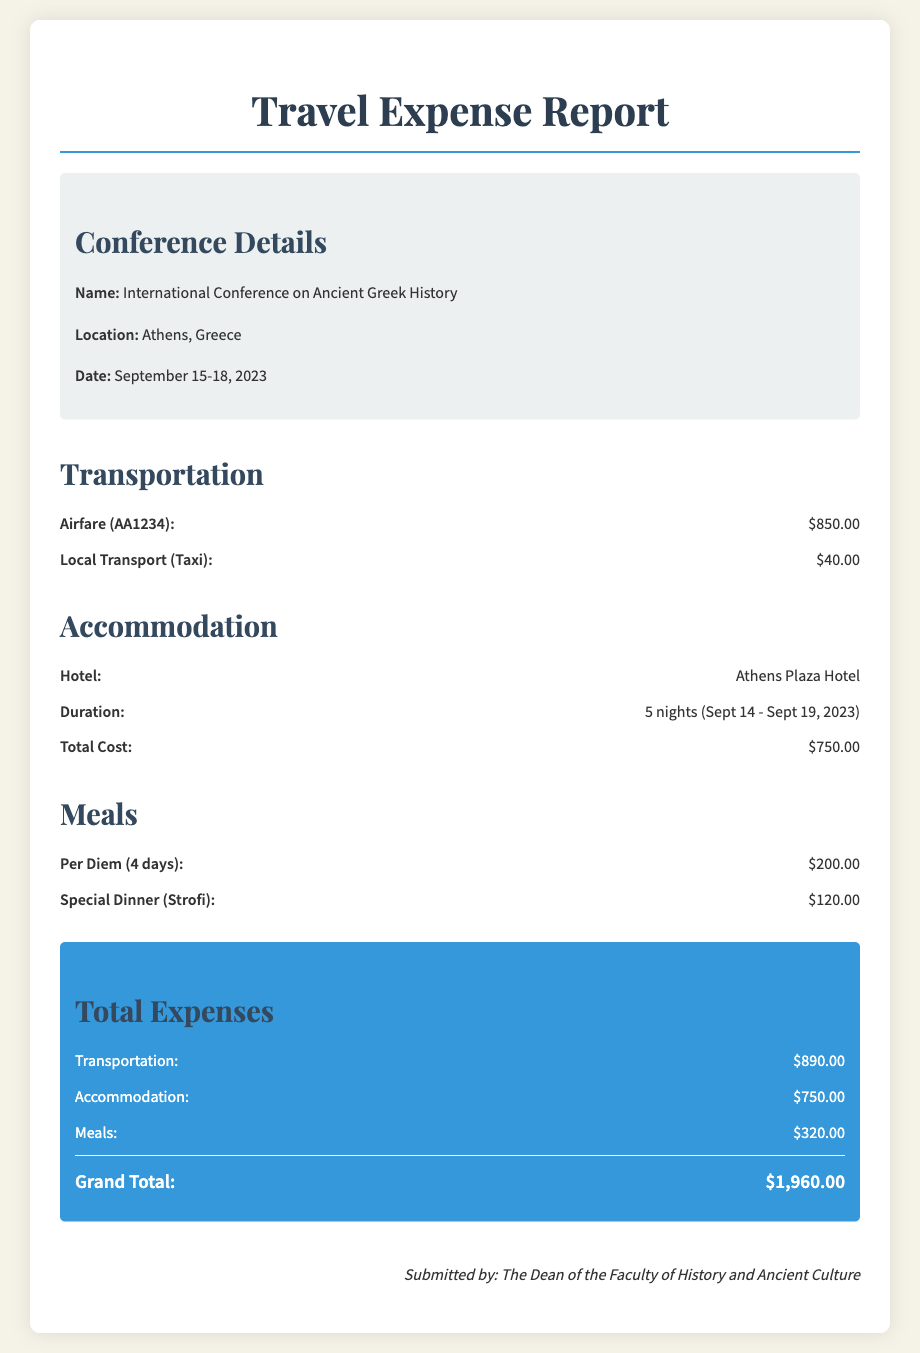what is the name of the conference? The name of the conference is explicitly stated in the document under conference details.
Answer: International Conference on Ancient Greek History where is the conference located? The location of the conference is mentioned in the conference details section of the document.
Answer: Athens, Greece what is the total cost of accommodation? The total cost of accommodation is directly stated in the accommodation section of the document.
Answer: $750.00 how many nights did the accommodation last? The duration of the accommodation is specified in the document along with the dates.
Answer: 5 nights what is the total cost for meals? The document provides a detailed breakdown of meal costs, leading to the total being mentioned.
Answer: $320.00 what was the airfare cost? The airfare cost is listed under the transportation section of the document.
Answer: $850.00 how much was spent on local transport? The expense for local transport is included in the transportation section of the document.
Answer: $40.00 what is the grand total of expenses? The grand total is the sum of all expense categories listed at the end of the document.
Answer: $1,960.00 how many days of per diem were claimed? The number of days for which per diem was claimed is mentioned in the meals section.
Answer: 4 days 